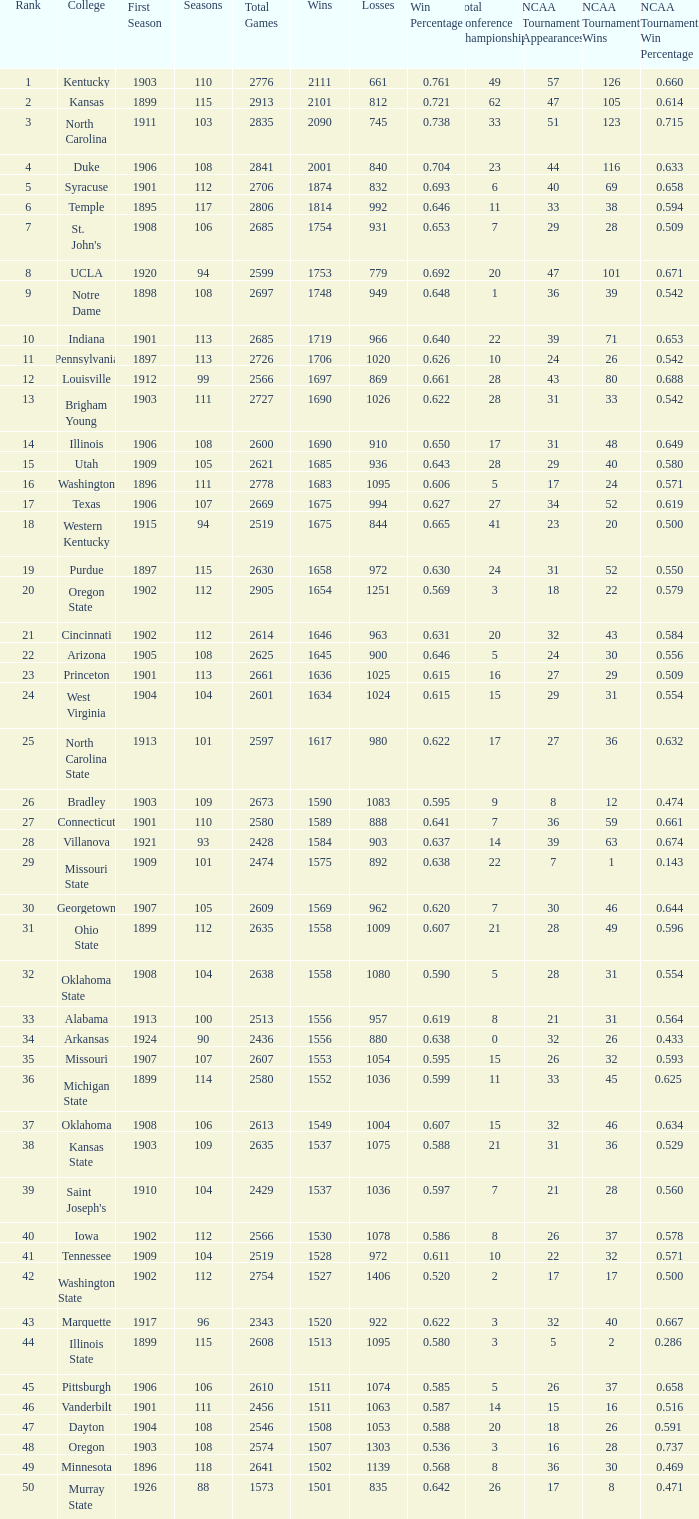What is the total of First Season games with 1537 Wins and a Season greater than 109? None. 